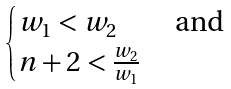<formula> <loc_0><loc_0><loc_500><loc_500>\begin{cases} w _ { 1 } < w _ { 2 } & \text { and} \\ n + 2 < \frac { w _ { 2 } } { w _ { 1 } } & \, \end{cases}</formula> 